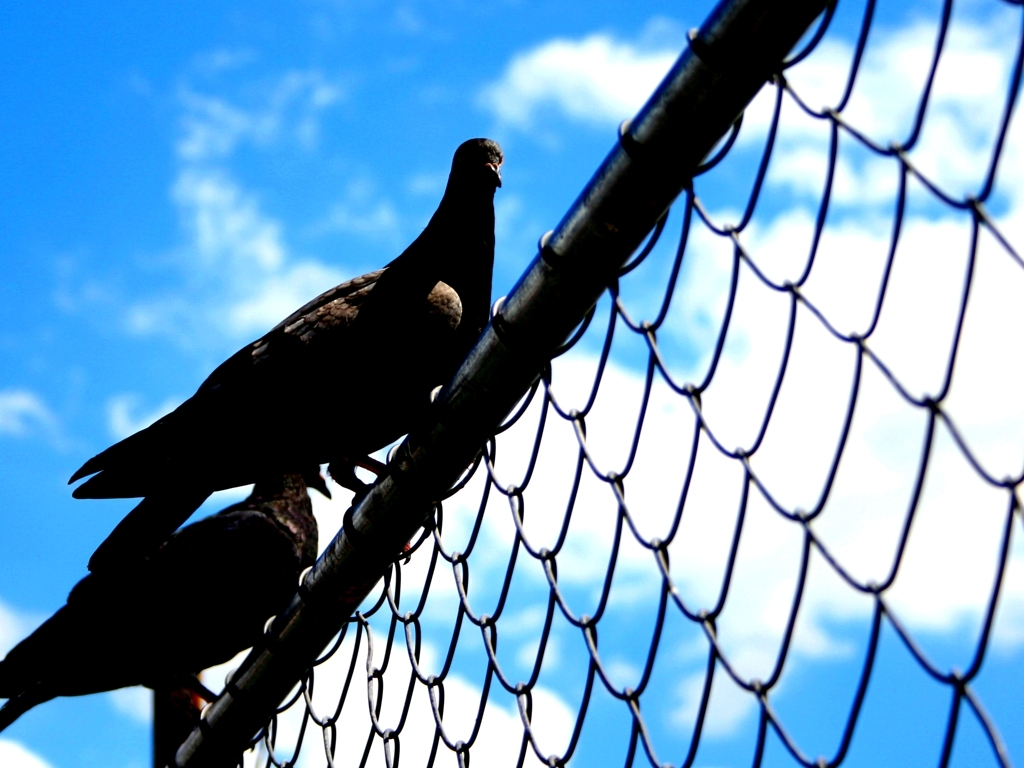Are the details of the wire fence accurately presented?
A. Yes
B. No
Answer with the option's letter from the given choices directly.
 A. 